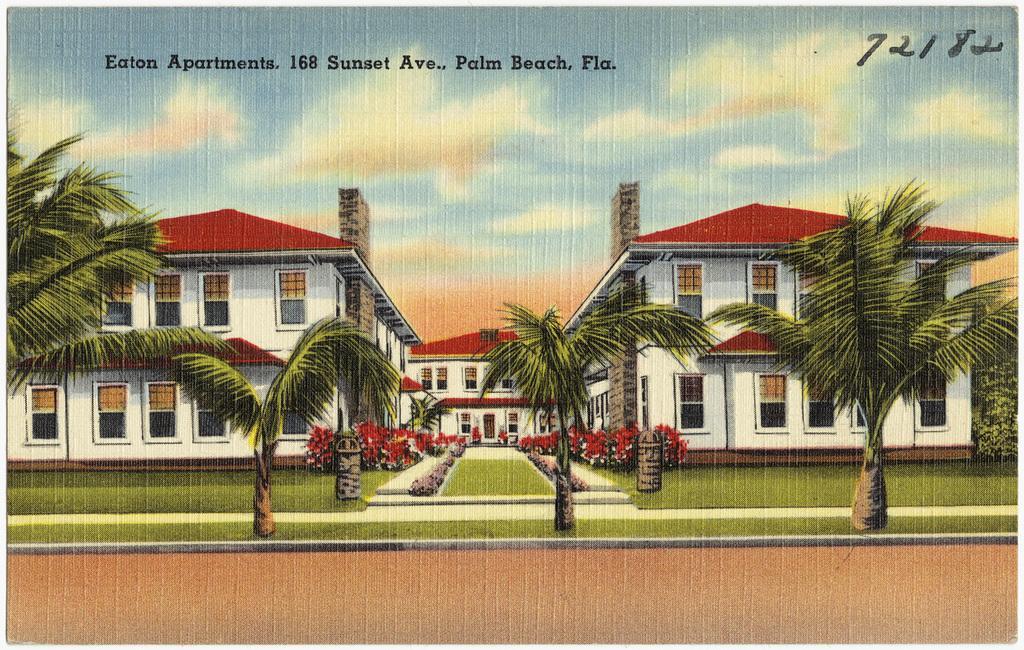Please provide a concise description of this image. In this image we can see depictions of buildings, trees,sky. At the top of the image there is some text. 